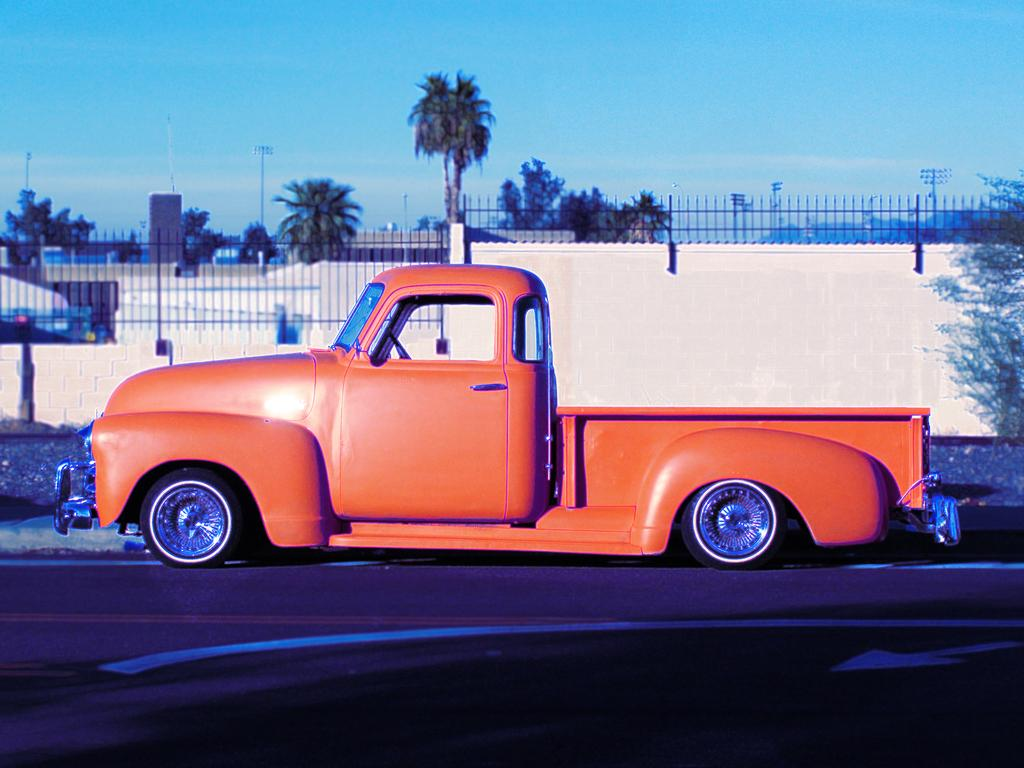What is the main subject in the foreground of the image? There is a vehicle in the foreground of the image. Where is the vehicle located? The vehicle is on the road. What can be seen in the background of the image? There is a fence, trees, light poles, and the sky visible in the background of the image. What type of agreement is being discussed by the people in the image? There are no people visible in the image, and therefore no discussion or agreement can be observed. 